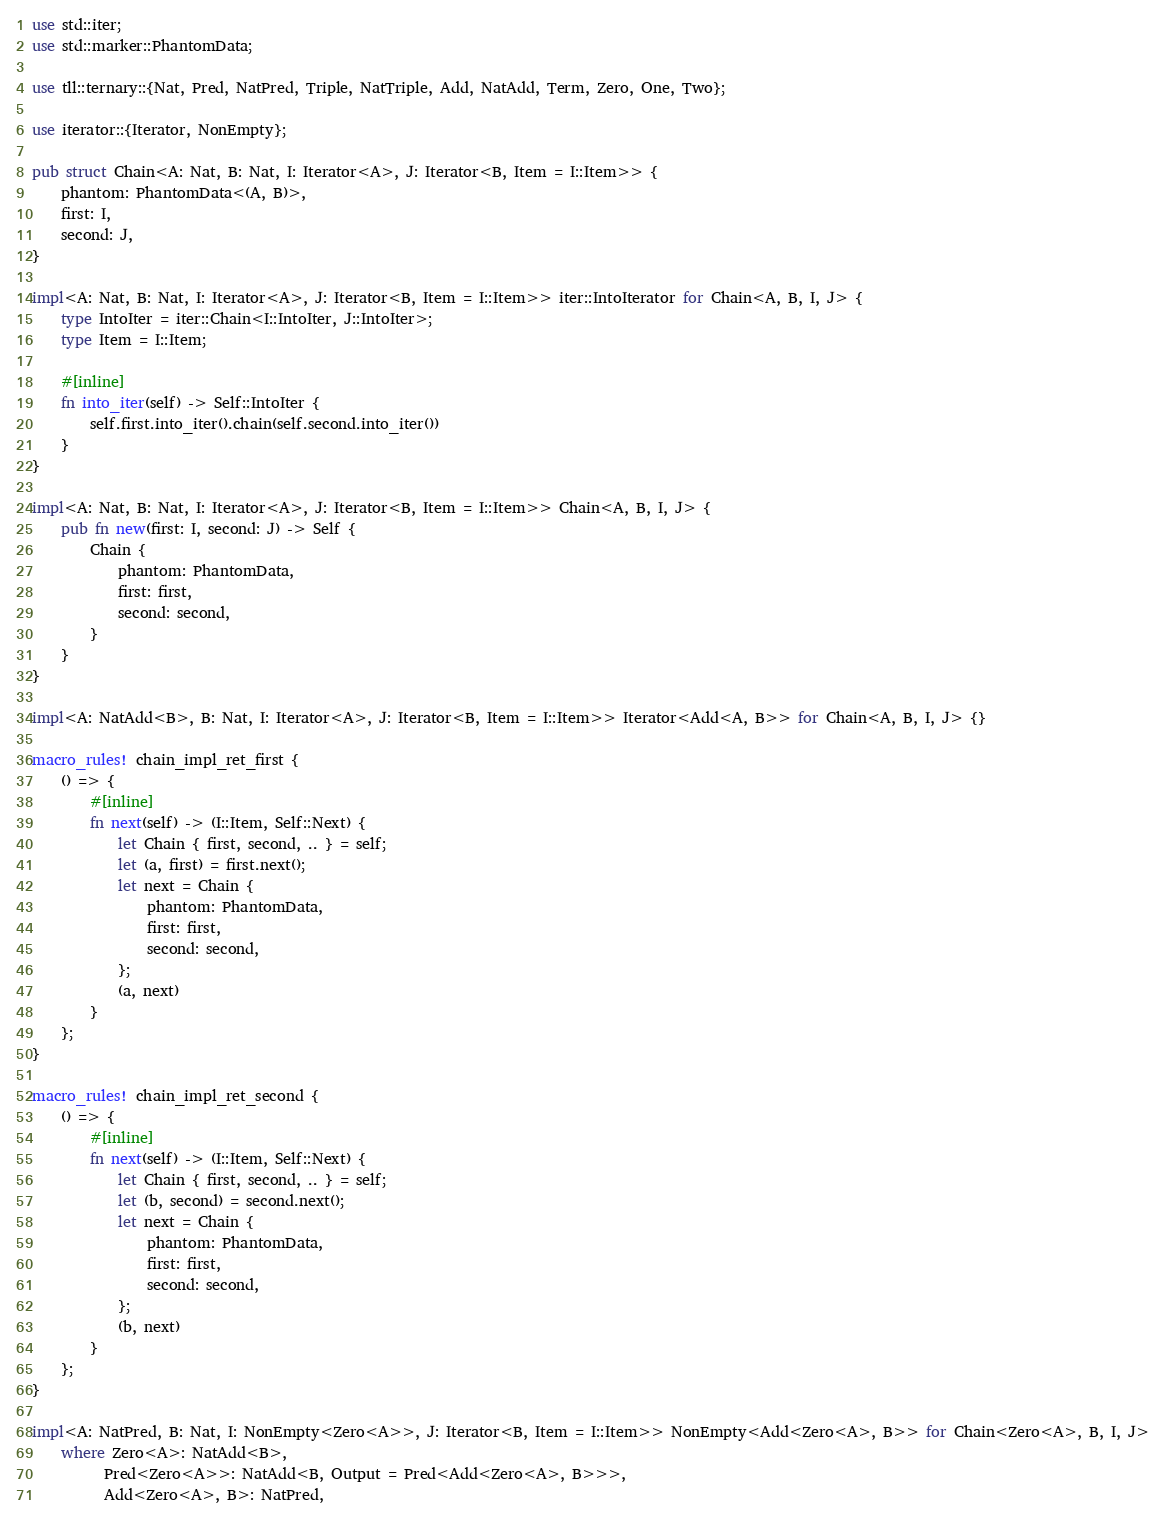<code> <loc_0><loc_0><loc_500><loc_500><_Rust_>use std::iter;
use std::marker::PhantomData;

use tll::ternary::{Nat, Pred, NatPred, Triple, NatTriple, Add, NatAdd, Term, Zero, One, Two};

use iterator::{Iterator, NonEmpty};

pub struct Chain<A: Nat, B: Nat, I: Iterator<A>, J: Iterator<B, Item = I::Item>> {
    phantom: PhantomData<(A, B)>,
    first: I,
    second: J,
}

impl<A: Nat, B: Nat, I: Iterator<A>, J: Iterator<B, Item = I::Item>> iter::IntoIterator for Chain<A, B, I, J> {
    type IntoIter = iter::Chain<I::IntoIter, J::IntoIter>;
    type Item = I::Item;

    #[inline]
    fn into_iter(self) -> Self::IntoIter {
        self.first.into_iter().chain(self.second.into_iter())
    }
}

impl<A: Nat, B: Nat, I: Iterator<A>, J: Iterator<B, Item = I::Item>> Chain<A, B, I, J> {
    pub fn new(first: I, second: J) -> Self {
        Chain {
            phantom: PhantomData,
            first: first,
            second: second,
        }
    }
}

impl<A: NatAdd<B>, B: Nat, I: Iterator<A>, J: Iterator<B, Item = I::Item>> Iterator<Add<A, B>> for Chain<A, B, I, J> {}

macro_rules! chain_impl_ret_first {
    () => {
        #[inline]
        fn next(self) -> (I::Item, Self::Next) {
            let Chain { first, second, .. } = self;
            let (a, first) = first.next();
            let next = Chain {
                phantom: PhantomData,
                first: first,
                second: second,
            };
            (a, next)
        }
    };
}

macro_rules! chain_impl_ret_second {
    () => {
        #[inline]
        fn next(self) -> (I::Item, Self::Next) {
            let Chain { first, second, .. } = self;
            let (b, second) = second.next();
            let next = Chain {
                phantom: PhantomData,
                first: first,
                second: second,
            };
            (b, next)
        }
    };
}

impl<A: NatPred, B: Nat, I: NonEmpty<Zero<A>>, J: Iterator<B, Item = I::Item>> NonEmpty<Add<Zero<A>, B>> for Chain<Zero<A>, B, I, J>
    where Zero<A>: NatAdd<B>,
          Pred<Zero<A>>: NatAdd<B, Output = Pred<Add<Zero<A>, B>>>,
          Add<Zero<A>, B>: NatPred,</code> 